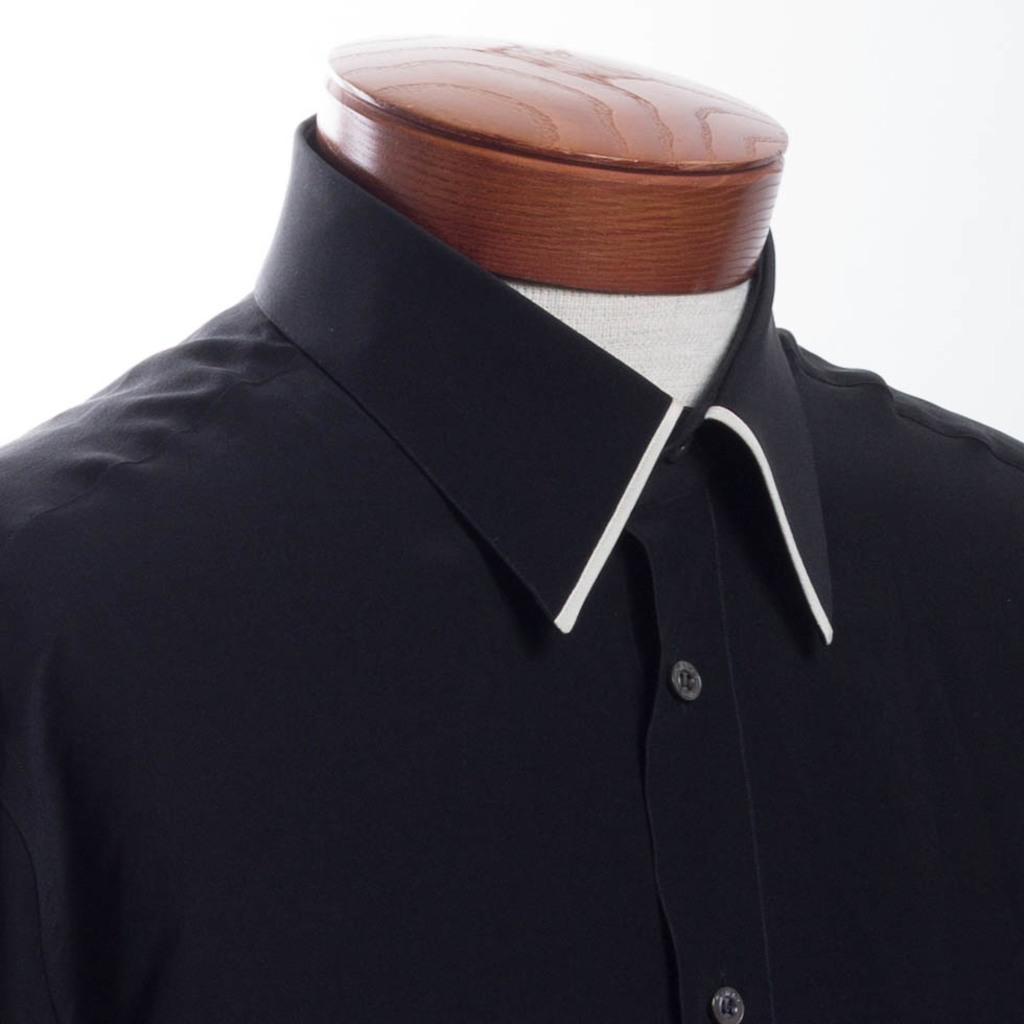Please provide a concise description of this image. In the picture we can see a shirt and a mannequin. There is a white background. 